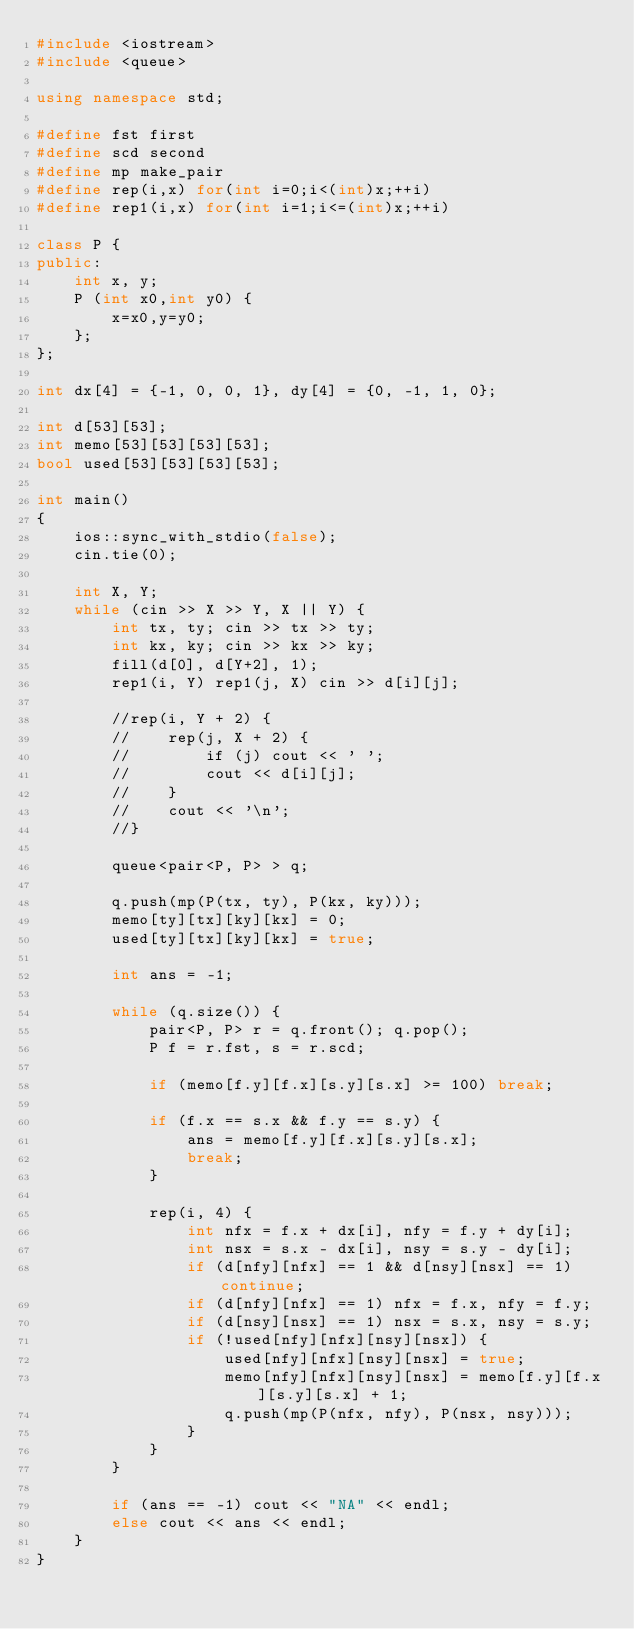Convert code to text. <code><loc_0><loc_0><loc_500><loc_500><_C++_>#include <iostream>
#include <queue>

using namespace std;

#define fst first
#define scd second
#define mp make_pair
#define rep(i,x) for(int i=0;i<(int)x;++i)
#define rep1(i,x) for(int i=1;i<=(int)x;++i)

class P {
public:
    int x, y;
    P (int x0,int y0) {
        x=x0,y=y0;
    };
};

int dx[4] = {-1, 0, 0, 1}, dy[4] = {0, -1, 1, 0};

int d[53][53];
int memo[53][53][53][53];
bool used[53][53][53][53];

int main()
{
    ios::sync_with_stdio(false);
    cin.tie(0);

    int X, Y;
    while (cin >> X >> Y, X || Y) {
        int tx, ty; cin >> tx >> ty;
        int kx, ky; cin >> kx >> ky;
        fill(d[0], d[Y+2], 1);
        rep1(i, Y) rep1(j, X) cin >> d[i][j];

        //rep(i, Y + 2) {
        //    rep(j, X + 2) {
        //        if (j) cout << ' ';
        //        cout << d[i][j];
        //    }
        //    cout << '\n';
        //}

        queue<pair<P, P> > q;

        q.push(mp(P(tx, ty), P(kx, ky)));
        memo[ty][tx][ky][kx] = 0;
        used[ty][tx][ky][kx] = true;

        int ans = -1;

        while (q.size()) {
            pair<P, P> r = q.front(); q.pop();
            P f = r.fst, s = r.scd;

            if (memo[f.y][f.x][s.y][s.x] >= 100) break;

            if (f.x == s.x && f.y == s.y) {
                ans = memo[f.y][f.x][s.y][s.x];
                break;
            }

            rep(i, 4) {
                int nfx = f.x + dx[i], nfy = f.y + dy[i];
                int nsx = s.x - dx[i], nsy = s.y - dy[i];
                if (d[nfy][nfx] == 1 && d[nsy][nsx] == 1) continue;
                if (d[nfy][nfx] == 1) nfx = f.x, nfy = f.y;
                if (d[nsy][nsx] == 1) nsx = s.x, nsy = s.y;
                if (!used[nfy][nfx][nsy][nsx]) {
                    used[nfy][nfx][nsy][nsx] = true;
                    memo[nfy][nfx][nsy][nsx] = memo[f.y][f.x][s.y][s.x] + 1;
                    q.push(mp(P(nfx, nfy), P(nsx, nsy)));
                }
            }
        }

        if (ans == -1) cout << "NA" << endl;
        else cout << ans << endl;
    }
}</code> 